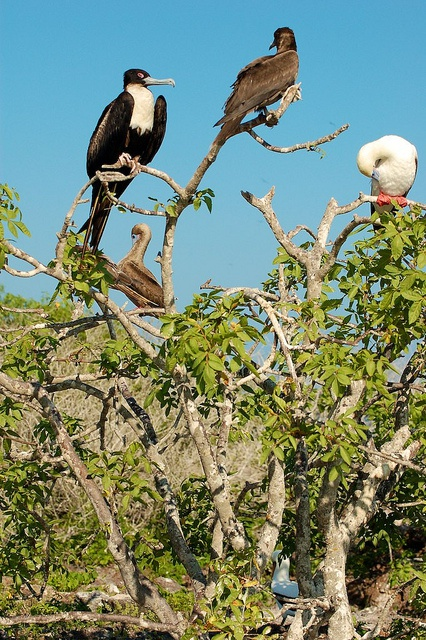Describe the objects in this image and their specific colors. I can see bird in lightblue, black, tan, beige, and maroon tones, bird in lightblue, ivory, tan, and olive tones, bird in lightblue, maroon, black, and gray tones, and bird in lightblue, maroon, gray, and tan tones in this image. 